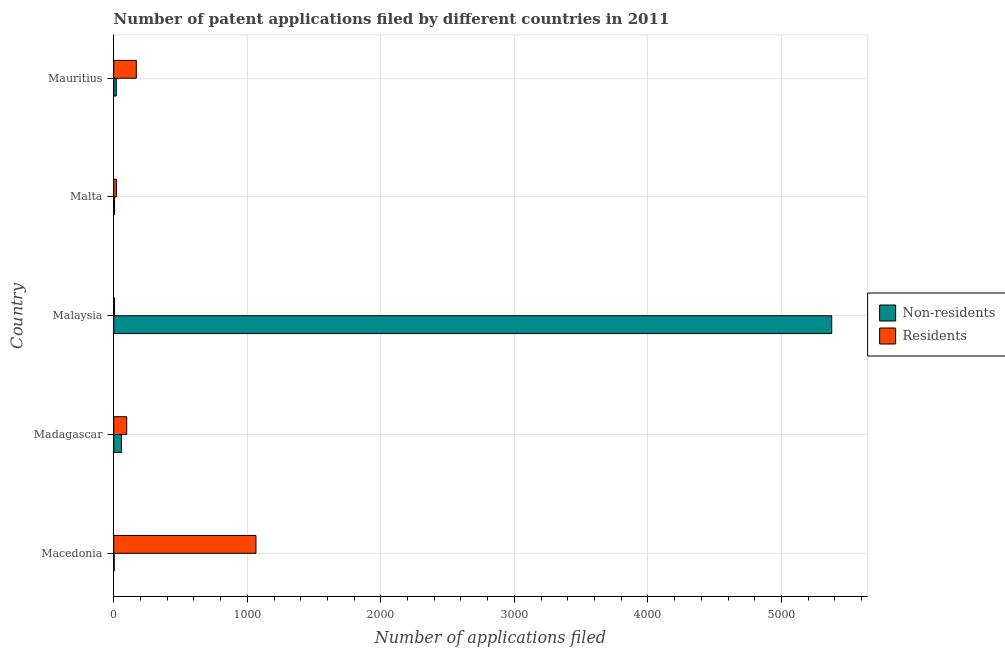How many different coloured bars are there?
Your response must be concise. 2. How many groups of bars are there?
Keep it short and to the point. 5. Are the number of bars per tick equal to the number of legend labels?
Offer a very short reply. Yes. Are the number of bars on each tick of the Y-axis equal?
Your response must be concise. Yes. How many bars are there on the 2nd tick from the top?
Provide a short and direct response. 2. What is the label of the 1st group of bars from the top?
Your answer should be compact. Mauritius. What is the number of patent applications by non residents in Madagascar?
Provide a short and direct response. 58. Across all countries, what is the maximum number of patent applications by residents?
Make the answer very short. 1065. Across all countries, what is the minimum number of patent applications by non residents?
Your response must be concise. 3. In which country was the number of patent applications by non residents maximum?
Your answer should be very brief. Malaysia. In which country was the number of patent applications by non residents minimum?
Offer a very short reply. Macedonia. What is the total number of patent applications by residents in the graph?
Your answer should be compact. 1357. What is the difference between the number of patent applications by non residents in Madagascar and that in Malaysia?
Offer a terse response. -5318. What is the difference between the number of patent applications by residents in Madagascar and the number of patent applications by non residents in Malta?
Provide a short and direct response. 91. What is the average number of patent applications by non residents per country?
Keep it short and to the point. 1092.4. What is the difference between the number of patent applications by non residents and number of patent applications by residents in Malta?
Provide a short and direct response. -14. What is the ratio of the number of patent applications by residents in Madagascar to that in Mauritius?
Keep it short and to the point. 0.57. Is the difference between the number of patent applications by residents in Malta and Mauritius greater than the difference between the number of patent applications by non residents in Malta and Mauritius?
Provide a succinct answer. No. What is the difference between the highest and the second highest number of patent applications by non residents?
Provide a short and direct response. 5318. What is the difference between the highest and the lowest number of patent applications by non residents?
Offer a very short reply. 5373. In how many countries, is the number of patent applications by non residents greater than the average number of patent applications by non residents taken over all countries?
Your answer should be very brief. 1. What does the 1st bar from the top in Madagascar represents?
Provide a succinct answer. Residents. What does the 1st bar from the bottom in Madagascar represents?
Give a very brief answer. Non-residents. How many bars are there?
Your response must be concise. 10. Are all the bars in the graph horizontal?
Provide a short and direct response. Yes. Are the values on the major ticks of X-axis written in scientific E-notation?
Provide a succinct answer. No. How many legend labels are there?
Give a very brief answer. 2. What is the title of the graph?
Keep it short and to the point. Number of patent applications filed by different countries in 2011. What is the label or title of the X-axis?
Provide a short and direct response. Number of applications filed. What is the Number of applications filed in Non-residents in Macedonia?
Give a very brief answer. 3. What is the Number of applications filed in Residents in Macedonia?
Your answer should be compact. 1065. What is the Number of applications filed in Non-residents in Madagascar?
Ensure brevity in your answer.  58. What is the Number of applications filed in Residents in Madagascar?
Offer a terse response. 97. What is the Number of applications filed of Non-residents in Malaysia?
Ensure brevity in your answer.  5376. What is the Number of applications filed of Non-residents in Malta?
Keep it short and to the point. 6. What is the Number of applications filed in Non-residents in Mauritius?
Your answer should be compact. 19. What is the Number of applications filed of Residents in Mauritius?
Offer a terse response. 169. Across all countries, what is the maximum Number of applications filed in Non-residents?
Your response must be concise. 5376. Across all countries, what is the maximum Number of applications filed in Residents?
Provide a succinct answer. 1065. Across all countries, what is the minimum Number of applications filed in Non-residents?
Provide a succinct answer. 3. Across all countries, what is the minimum Number of applications filed in Residents?
Give a very brief answer. 6. What is the total Number of applications filed in Non-residents in the graph?
Provide a short and direct response. 5462. What is the total Number of applications filed in Residents in the graph?
Make the answer very short. 1357. What is the difference between the Number of applications filed in Non-residents in Macedonia and that in Madagascar?
Make the answer very short. -55. What is the difference between the Number of applications filed of Residents in Macedonia and that in Madagascar?
Provide a succinct answer. 968. What is the difference between the Number of applications filed in Non-residents in Macedonia and that in Malaysia?
Your response must be concise. -5373. What is the difference between the Number of applications filed of Residents in Macedonia and that in Malaysia?
Offer a terse response. 1059. What is the difference between the Number of applications filed in Residents in Macedonia and that in Malta?
Give a very brief answer. 1045. What is the difference between the Number of applications filed of Residents in Macedonia and that in Mauritius?
Your answer should be compact. 896. What is the difference between the Number of applications filed in Non-residents in Madagascar and that in Malaysia?
Provide a succinct answer. -5318. What is the difference between the Number of applications filed in Residents in Madagascar and that in Malaysia?
Your response must be concise. 91. What is the difference between the Number of applications filed of Non-residents in Madagascar and that in Mauritius?
Give a very brief answer. 39. What is the difference between the Number of applications filed of Residents in Madagascar and that in Mauritius?
Give a very brief answer. -72. What is the difference between the Number of applications filed in Non-residents in Malaysia and that in Malta?
Provide a succinct answer. 5370. What is the difference between the Number of applications filed of Non-residents in Malaysia and that in Mauritius?
Keep it short and to the point. 5357. What is the difference between the Number of applications filed in Residents in Malaysia and that in Mauritius?
Provide a succinct answer. -163. What is the difference between the Number of applications filed in Non-residents in Malta and that in Mauritius?
Your answer should be very brief. -13. What is the difference between the Number of applications filed of Residents in Malta and that in Mauritius?
Your answer should be very brief. -149. What is the difference between the Number of applications filed in Non-residents in Macedonia and the Number of applications filed in Residents in Madagascar?
Offer a very short reply. -94. What is the difference between the Number of applications filed of Non-residents in Macedonia and the Number of applications filed of Residents in Malta?
Provide a succinct answer. -17. What is the difference between the Number of applications filed in Non-residents in Macedonia and the Number of applications filed in Residents in Mauritius?
Provide a short and direct response. -166. What is the difference between the Number of applications filed in Non-residents in Madagascar and the Number of applications filed in Residents in Malaysia?
Your answer should be very brief. 52. What is the difference between the Number of applications filed in Non-residents in Madagascar and the Number of applications filed in Residents in Mauritius?
Provide a short and direct response. -111. What is the difference between the Number of applications filed in Non-residents in Malaysia and the Number of applications filed in Residents in Malta?
Provide a succinct answer. 5356. What is the difference between the Number of applications filed in Non-residents in Malaysia and the Number of applications filed in Residents in Mauritius?
Ensure brevity in your answer.  5207. What is the difference between the Number of applications filed of Non-residents in Malta and the Number of applications filed of Residents in Mauritius?
Keep it short and to the point. -163. What is the average Number of applications filed of Non-residents per country?
Your answer should be very brief. 1092.4. What is the average Number of applications filed in Residents per country?
Provide a short and direct response. 271.4. What is the difference between the Number of applications filed of Non-residents and Number of applications filed of Residents in Macedonia?
Provide a short and direct response. -1062. What is the difference between the Number of applications filed of Non-residents and Number of applications filed of Residents in Madagascar?
Keep it short and to the point. -39. What is the difference between the Number of applications filed in Non-residents and Number of applications filed in Residents in Malaysia?
Your response must be concise. 5370. What is the difference between the Number of applications filed in Non-residents and Number of applications filed in Residents in Malta?
Ensure brevity in your answer.  -14. What is the difference between the Number of applications filed in Non-residents and Number of applications filed in Residents in Mauritius?
Your answer should be compact. -150. What is the ratio of the Number of applications filed of Non-residents in Macedonia to that in Madagascar?
Ensure brevity in your answer.  0.05. What is the ratio of the Number of applications filed in Residents in Macedonia to that in Madagascar?
Your response must be concise. 10.98. What is the ratio of the Number of applications filed of Non-residents in Macedonia to that in Malaysia?
Provide a succinct answer. 0. What is the ratio of the Number of applications filed of Residents in Macedonia to that in Malaysia?
Offer a very short reply. 177.5. What is the ratio of the Number of applications filed of Residents in Macedonia to that in Malta?
Offer a terse response. 53.25. What is the ratio of the Number of applications filed in Non-residents in Macedonia to that in Mauritius?
Your answer should be very brief. 0.16. What is the ratio of the Number of applications filed of Residents in Macedonia to that in Mauritius?
Your answer should be compact. 6.3. What is the ratio of the Number of applications filed of Non-residents in Madagascar to that in Malaysia?
Ensure brevity in your answer.  0.01. What is the ratio of the Number of applications filed of Residents in Madagascar to that in Malaysia?
Offer a very short reply. 16.17. What is the ratio of the Number of applications filed in Non-residents in Madagascar to that in Malta?
Give a very brief answer. 9.67. What is the ratio of the Number of applications filed of Residents in Madagascar to that in Malta?
Your answer should be compact. 4.85. What is the ratio of the Number of applications filed of Non-residents in Madagascar to that in Mauritius?
Your answer should be compact. 3.05. What is the ratio of the Number of applications filed of Residents in Madagascar to that in Mauritius?
Offer a terse response. 0.57. What is the ratio of the Number of applications filed in Non-residents in Malaysia to that in Malta?
Your response must be concise. 896. What is the ratio of the Number of applications filed of Residents in Malaysia to that in Malta?
Offer a very short reply. 0.3. What is the ratio of the Number of applications filed in Non-residents in Malaysia to that in Mauritius?
Your answer should be compact. 282.95. What is the ratio of the Number of applications filed in Residents in Malaysia to that in Mauritius?
Provide a short and direct response. 0.04. What is the ratio of the Number of applications filed of Non-residents in Malta to that in Mauritius?
Provide a short and direct response. 0.32. What is the ratio of the Number of applications filed of Residents in Malta to that in Mauritius?
Your answer should be compact. 0.12. What is the difference between the highest and the second highest Number of applications filed in Non-residents?
Offer a terse response. 5318. What is the difference between the highest and the second highest Number of applications filed of Residents?
Give a very brief answer. 896. What is the difference between the highest and the lowest Number of applications filed in Non-residents?
Offer a very short reply. 5373. What is the difference between the highest and the lowest Number of applications filed in Residents?
Ensure brevity in your answer.  1059. 